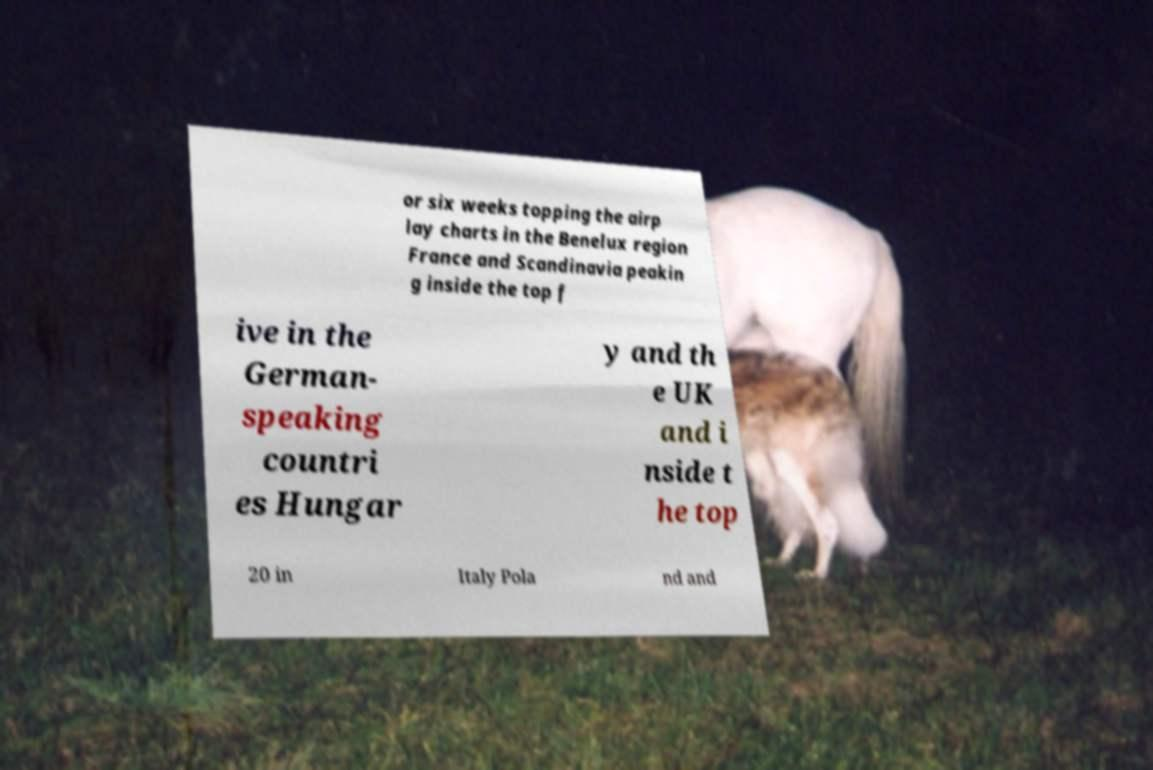Please read and relay the text visible in this image. What does it say? or six weeks topping the airp lay charts in the Benelux region France and Scandinavia peakin g inside the top f ive in the German- speaking countri es Hungar y and th e UK and i nside t he top 20 in Italy Pola nd and 